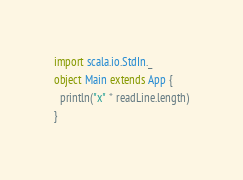Convert code to text. <code><loc_0><loc_0><loc_500><loc_500><_Scala_>import scala.io.StdIn._
object Main extends App {
  println("x" * readLine.length)
}
</code> 